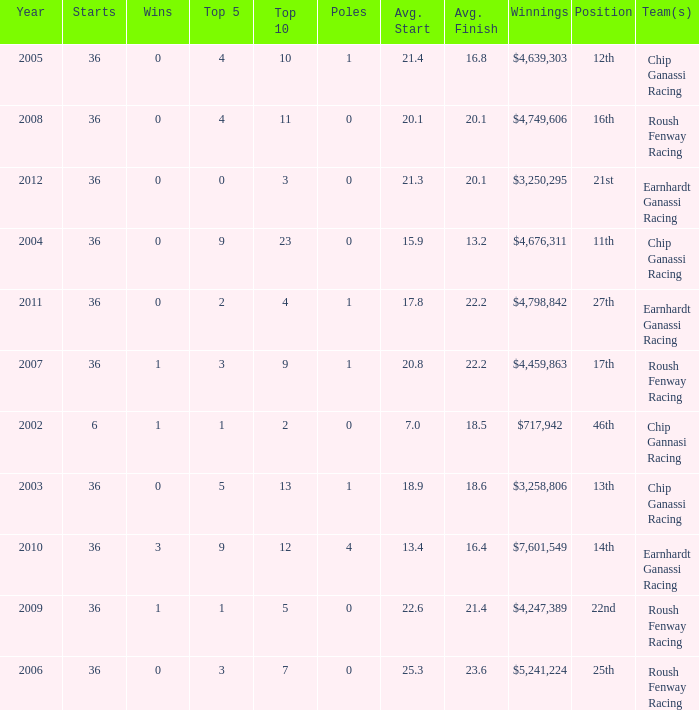Which stars correspond to the position number 16? 36.0. 